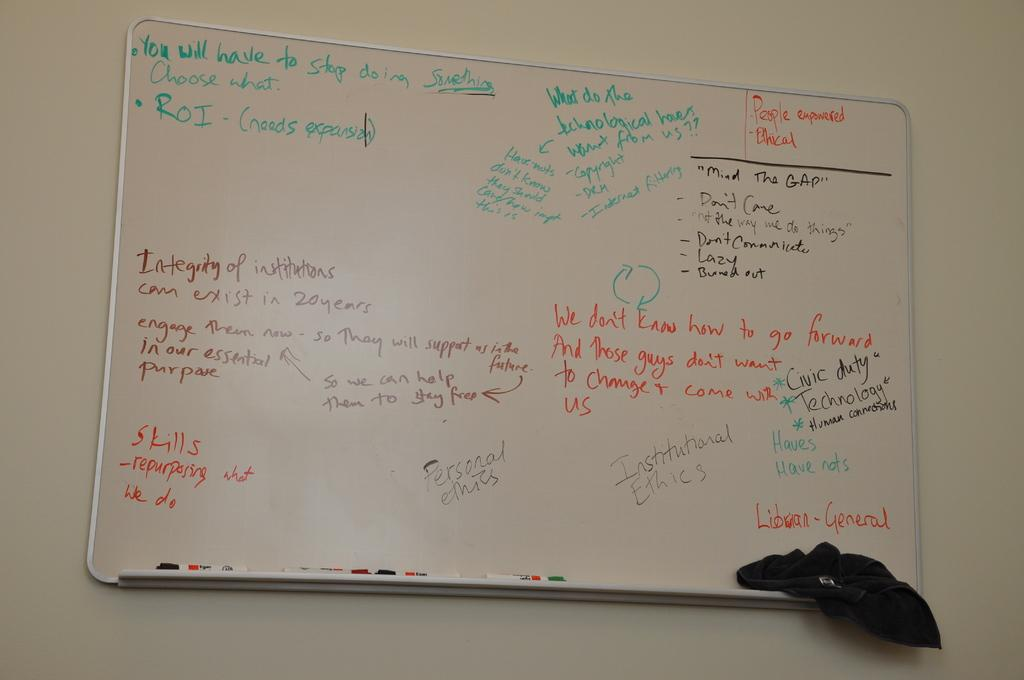<image>
Render a clear and concise summary of the photo. A white board has the word general in the bottom, right corner. 